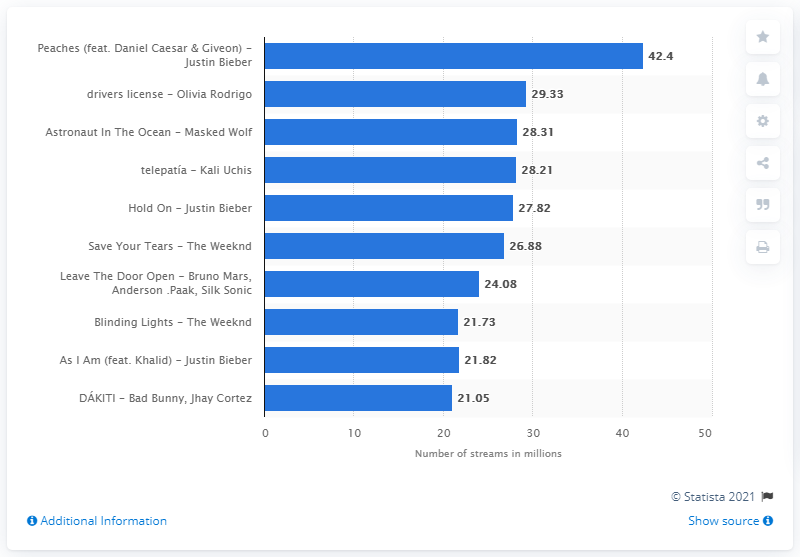Mention a couple of crucial points in this snapshot. Hold On has 27.82 streams. DAKITI has 21.05 streams. As of the most recent data available, "Peaches" had a total of 42.4 streams on Spotify. 